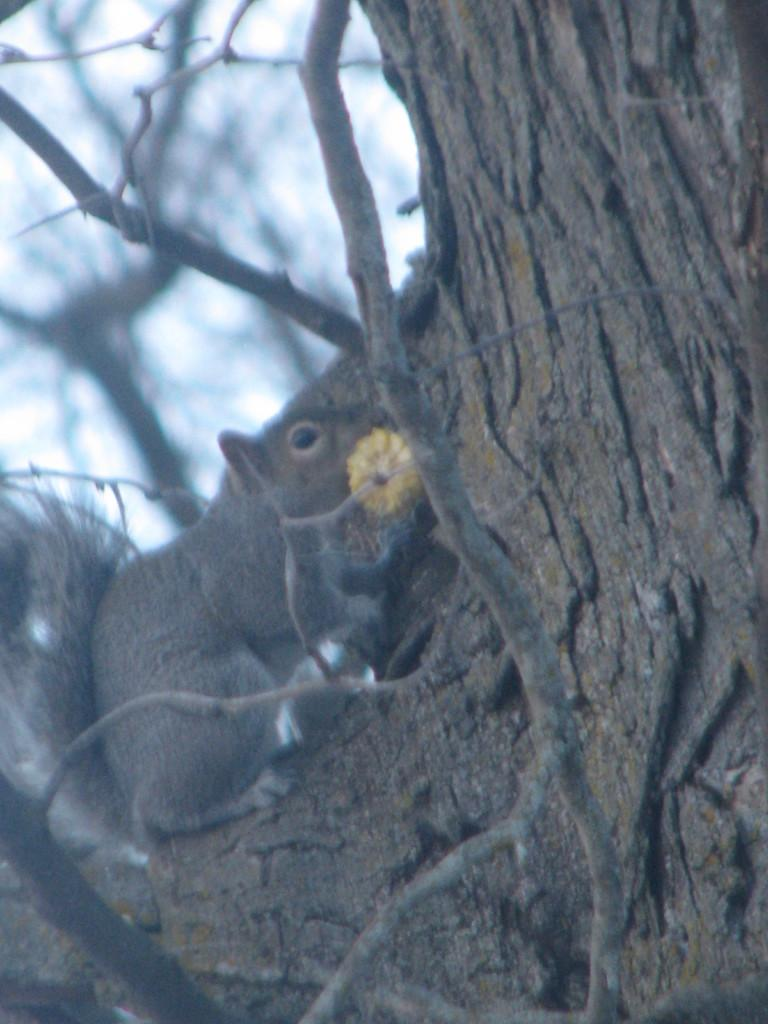What animal is present in the image? There is a squirrel in the image. Where is the squirrel located? The squirrel is on a tree. Can you describe the background of the image? The background of the image is blurred. What type of mitten is the snail wearing in the image? There is no snail or mitten present in the image; it features a squirrel on a tree with a blurred background. 